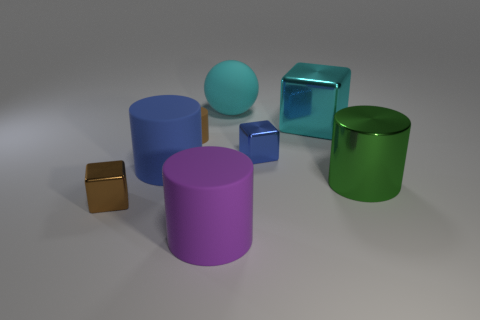Is there a yellow object of the same shape as the cyan rubber thing? After carefully examining the image, I can confirm that there isn't a yellow object that shares the same shape as the cyan rubber-looking item. The cyan object appears to be cylindrical with a rounded top, which is unique among the items present as the other objects with a similar shape do not share its color. 